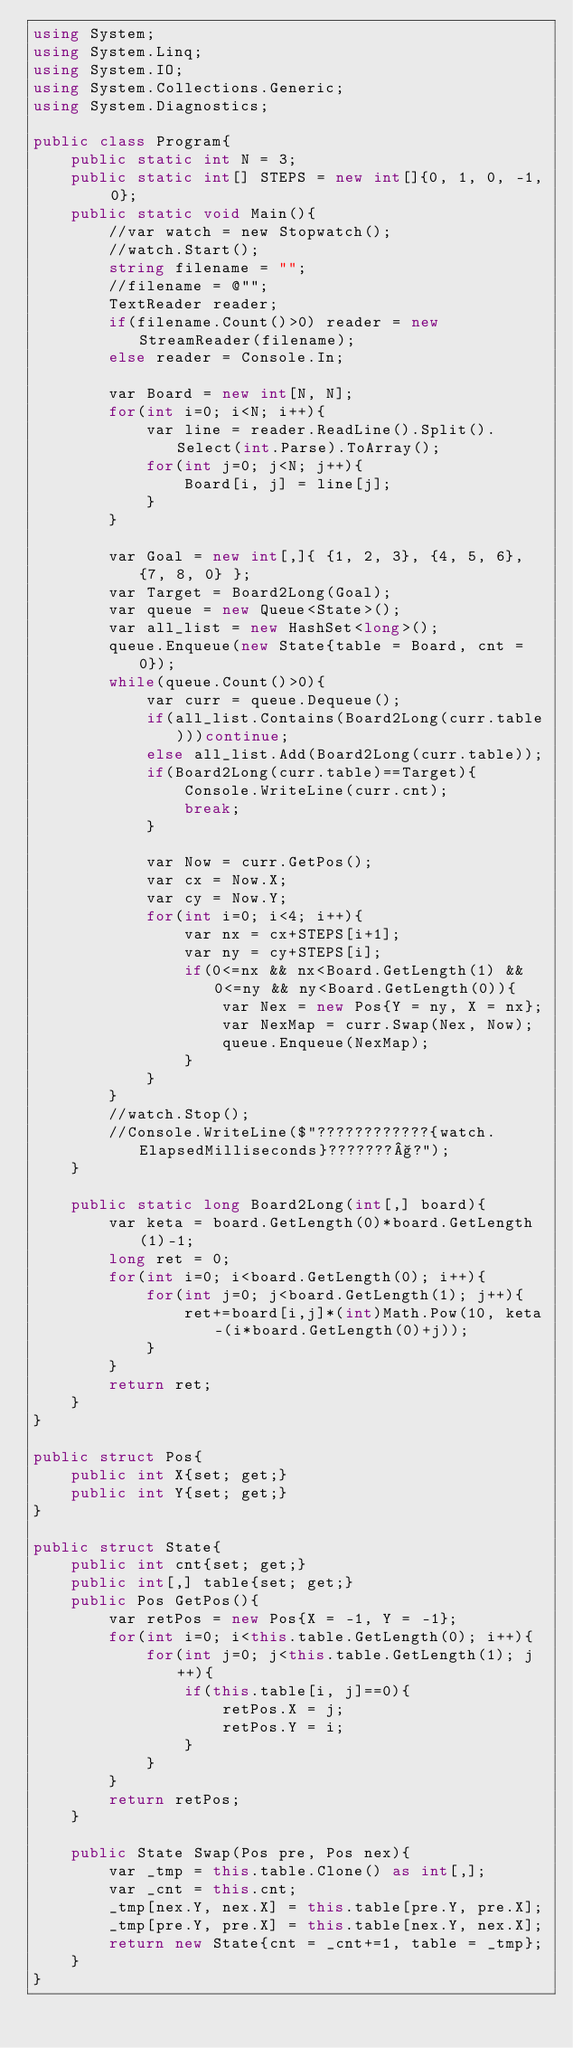<code> <loc_0><loc_0><loc_500><loc_500><_C#_>using System;
using System.Linq;
using System.IO;
using System.Collections.Generic;
using System.Diagnostics;

public class Program{
    public static int N = 3;
    public static int[] STEPS = new int[]{0, 1, 0, -1, 0};
    public static void Main(){
        //var watch = new Stopwatch();
        //watch.Start();
        string filename = "";
        //filename = @"";
        TextReader reader;
        if(filename.Count()>0) reader = new StreamReader(filename);
        else reader = Console.In;
        
        var Board = new int[N, N];
        for(int i=0; i<N; i++){
            var line = reader.ReadLine().Split().Select(int.Parse).ToArray();
            for(int j=0; j<N; j++){
                Board[i, j] = line[j];
            }
        }
        
        var Goal = new int[,]{ {1, 2, 3}, {4, 5, 6}, {7, 8, 0} };
        var Target = Board2Long(Goal);
        var queue = new Queue<State>();
        var all_list = new HashSet<long>();
        queue.Enqueue(new State{table = Board, cnt = 0});
        while(queue.Count()>0){
            var curr = queue.Dequeue();
            if(all_list.Contains(Board2Long(curr.table)))continue;
            else all_list.Add(Board2Long(curr.table));
            if(Board2Long(curr.table)==Target){
                Console.WriteLine(curr.cnt);
                break;
            }

            var Now = curr.GetPos();
            var cx = Now.X;
            var cy = Now.Y;
            for(int i=0; i<4; i++){
                var nx = cx+STEPS[i+1]; 
                var ny = cy+STEPS[i];
                if(0<=nx && nx<Board.GetLength(1) && 0<=ny && ny<Board.GetLength(0)){
                    var Nex = new Pos{Y = ny, X = nx};
                    var NexMap = curr.Swap(Nex, Now);
                    queue.Enqueue(NexMap);
                }
            }
        }
        //watch.Stop();
        //Console.WriteLine($"????????????{watch.ElapsedMilliseconds}???????§?");
    }

    public static long Board2Long(int[,] board){
        var keta = board.GetLength(0)*board.GetLength(1)-1;
        long ret = 0;
        for(int i=0; i<board.GetLength(0); i++){
            for(int j=0; j<board.GetLength(1); j++){
                ret+=board[i,j]*(int)Math.Pow(10, keta-(i*board.GetLength(0)+j));
            }
        }
        return ret;
    }
}

public struct Pos{
    public int X{set; get;}
    public int Y{set; get;}
}

public struct State{
    public int cnt{set; get;}
    public int[,] table{set; get;}
    public Pos GetPos(){
        var retPos = new Pos{X = -1, Y = -1};
        for(int i=0; i<this.table.GetLength(0); i++){
            for(int j=0; j<this.table.GetLength(1); j++){
                if(this.table[i, j]==0){
                    retPos.X = j;
                    retPos.Y = i;
                }
            }
        }
        return retPos;
    }

    public State Swap(Pos pre, Pos nex){
        var _tmp = this.table.Clone() as int[,];
        var _cnt = this.cnt;
        _tmp[nex.Y, nex.X] = this.table[pre.Y, pre.X];
        _tmp[pre.Y, pre.X] = this.table[nex.Y, nex.X];
        return new State{cnt = _cnt+=1, table = _tmp};
    }
}</code> 